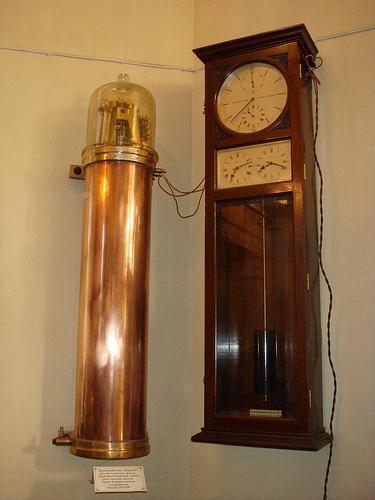How many objects are there?
Give a very brief answer. 2. 